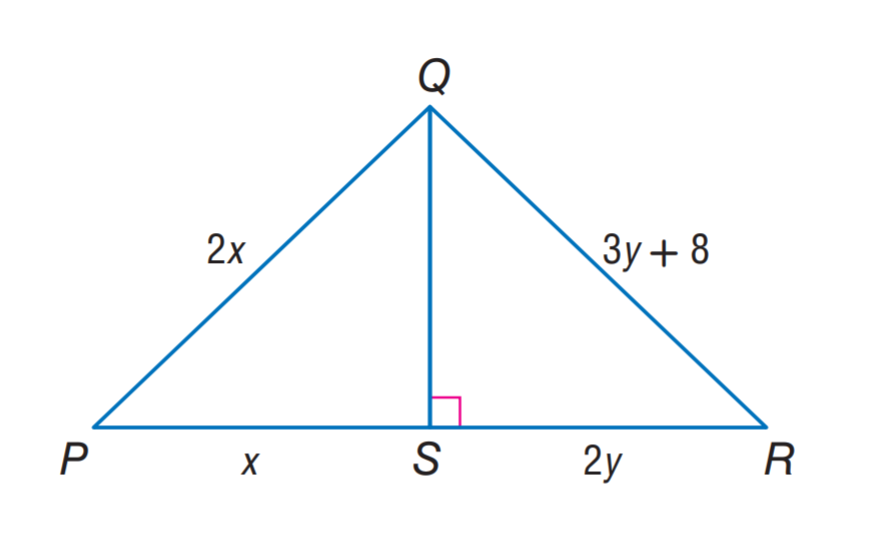Question: \triangle P Q S \cong \triangle R Q S. Find x.
Choices:
A. 8
B. 12
C. 16
D. 20
Answer with the letter. Answer: C Question: \triangle P Q S \cong \triangle R Q S. Find y.
Choices:
A. 8
B. 12
C. 16
D. 20
Answer with the letter. Answer: A 